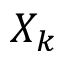<formula> <loc_0><loc_0><loc_500><loc_500>X _ { k }</formula> 